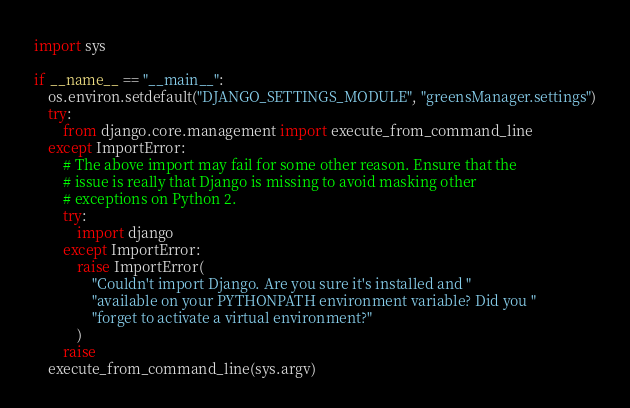Convert code to text. <code><loc_0><loc_0><loc_500><loc_500><_Python_>import sys

if __name__ == "__main__":
    os.environ.setdefault("DJANGO_SETTINGS_MODULE", "greensManager.settings")
    try:
        from django.core.management import execute_from_command_line
    except ImportError:
        # The above import may fail for some other reason. Ensure that the
        # issue is really that Django is missing to avoid masking other
        # exceptions on Python 2.
        try:
            import django
        except ImportError:
            raise ImportError(
                "Couldn't import Django. Are you sure it's installed and "
                "available on your PYTHONPATH environment variable? Did you "
                "forget to activate a virtual environment?"
            )
        raise
    execute_from_command_line(sys.argv)
</code> 